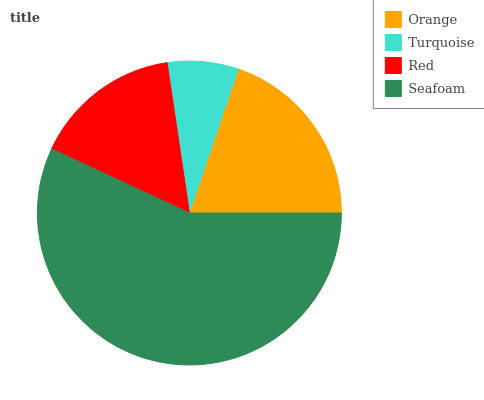Is Turquoise the minimum?
Answer yes or no. Yes. Is Seafoam the maximum?
Answer yes or no. Yes. Is Red the minimum?
Answer yes or no. No. Is Red the maximum?
Answer yes or no. No. Is Red greater than Turquoise?
Answer yes or no. Yes. Is Turquoise less than Red?
Answer yes or no. Yes. Is Turquoise greater than Red?
Answer yes or no. No. Is Red less than Turquoise?
Answer yes or no. No. Is Orange the high median?
Answer yes or no. Yes. Is Red the low median?
Answer yes or no. Yes. Is Seafoam the high median?
Answer yes or no. No. Is Orange the low median?
Answer yes or no. No. 